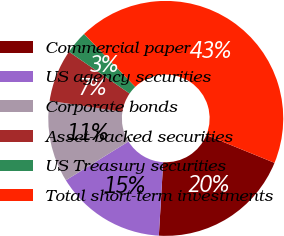Convert chart to OTSL. <chart><loc_0><loc_0><loc_500><loc_500><pie_chart><fcel>Commercial paper<fcel>US agency securities<fcel>Corporate bonds<fcel>Asset-backed securities<fcel>US Treasury securities<fcel>Total short-term investments<nl><fcel>19.76%<fcel>15.24%<fcel>11.22%<fcel>7.2%<fcel>3.17%<fcel>43.41%<nl></chart> 